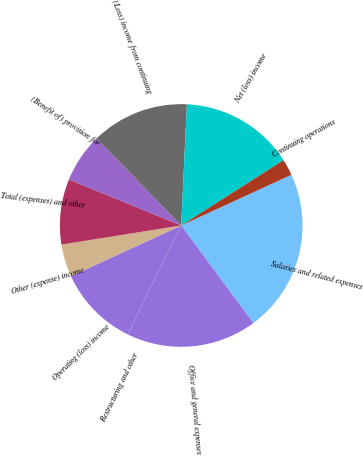Convert chart to OTSL. <chart><loc_0><loc_0><loc_500><loc_500><pie_chart><fcel>Salaries and related expenses<fcel>Office and general expenses<fcel>Restructuring and other<fcel>Operating (loss) income<fcel>Other (expense) income<fcel>Total (expenses) and other<fcel>(Benefit of) provision for<fcel>(Loss) income from continuing<fcel>Net (loss) income<fcel>Continuing operations<nl><fcel>21.73%<fcel>17.38%<fcel>0.01%<fcel>10.87%<fcel>4.35%<fcel>8.7%<fcel>6.52%<fcel>13.04%<fcel>15.21%<fcel>2.18%<nl></chart> 